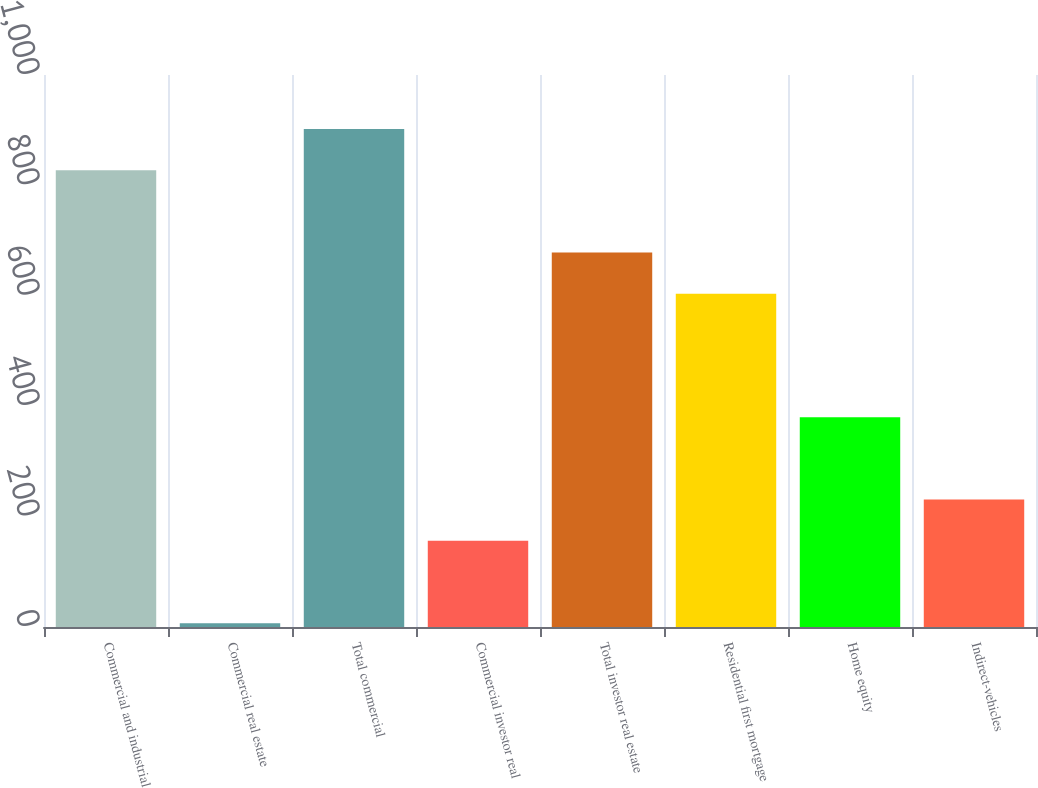<chart> <loc_0><loc_0><loc_500><loc_500><bar_chart><fcel>Commercial and industrial<fcel>Commercial real estate<fcel>Total commercial<fcel>Commercial investor real<fcel>Total investor real estate<fcel>Residential first mortgage<fcel>Home equity<fcel>Indirect-vehicles<nl><fcel>827.6<fcel>7<fcel>902.2<fcel>156.2<fcel>678.4<fcel>603.8<fcel>380<fcel>230.8<nl></chart> 